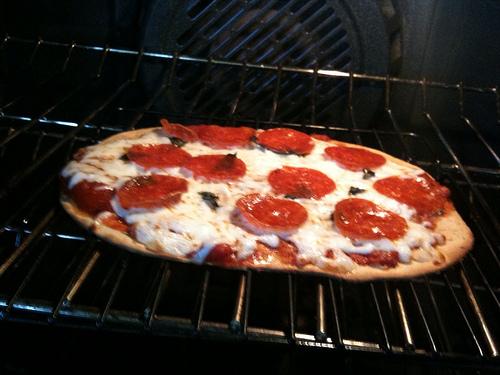Is there more than pepperoni on the pizza?
Answer briefly. Yes. Where is the pizza?
Concise answer only. In oven. What kind of food is this?
Keep it brief. Pizza. 